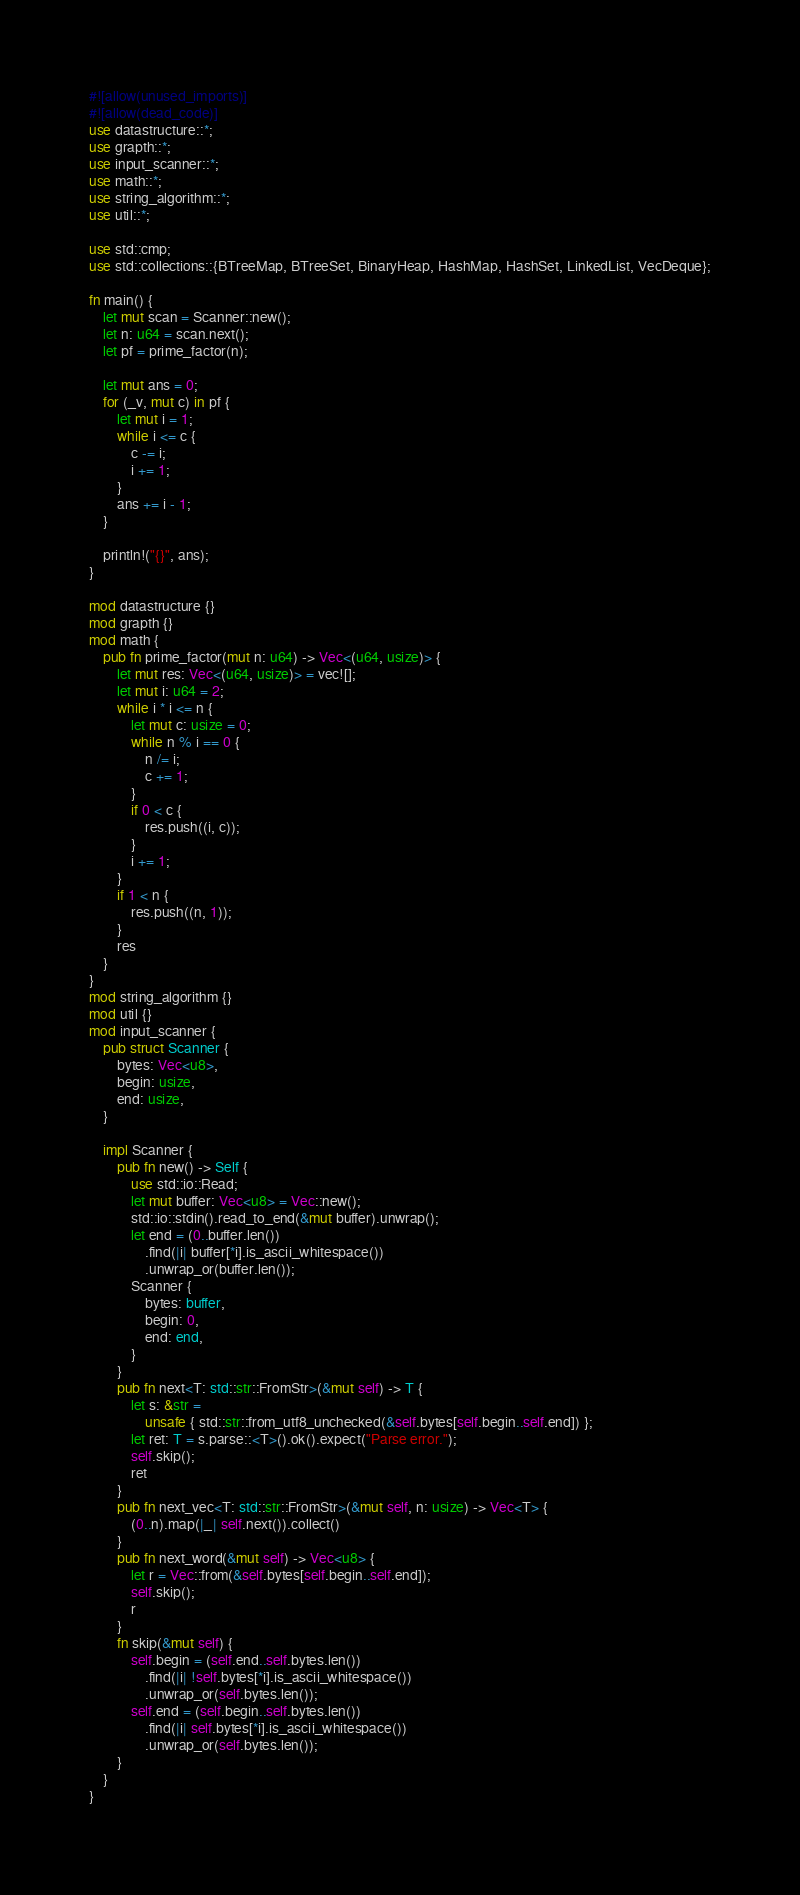Convert code to text. <code><loc_0><loc_0><loc_500><loc_500><_Rust_>#![allow(unused_imports)]
#![allow(dead_code)]
use datastructure::*;
use grapth::*;
use input_scanner::*;
use math::*;
use string_algorithm::*;
use util::*;

use std::cmp;
use std::collections::{BTreeMap, BTreeSet, BinaryHeap, HashMap, HashSet, LinkedList, VecDeque};

fn main() {
    let mut scan = Scanner::new();
    let n: u64 = scan.next();
    let pf = prime_factor(n);

    let mut ans = 0;
    for (_v, mut c) in pf {
        let mut i = 1;
        while i <= c {
            c -= i;
            i += 1;
        }
        ans += i - 1;
    }

    println!("{}", ans);
}

mod datastructure {}
mod grapth {}
mod math {
    pub fn prime_factor(mut n: u64) -> Vec<(u64, usize)> {
        let mut res: Vec<(u64, usize)> = vec![];
        let mut i: u64 = 2;
        while i * i <= n {
            let mut c: usize = 0;
            while n % i == 0 {
                n /= i;
                c += 1;
            }
            if 0 < c {
                res.push((i, c));
            }
            i += 1;
        }
        if 1 < n {
            res.push((n, 1));
        }
        res
    }
}
mod string_algorithm {}
mod util {}
mod input_scanner {
    pub struct Scanner {
        bytes: Vec<u8>,
        begin: usize,
        end: usize,
    }

    impl Scanner {
        pub fn new() -> Self {
            use std::io::Read;
            let mut buffer: Vec<u8> = Vec::new();
            std::io::stdin().read_to_end(&mut buffer).unwrap();
            let end = (0..buffer.len())
                .find(|i| buffer[*i].is_ascii_whitespace())
                .unwrap_or(buffer.len());
            Scanner {
                bytes: buffer,
                begin: 0,
                end: end,
            }
        }
        pub fn next<T: std::str::FromStr>(&mut self) -> T {
            let s: &str =
                unsafe { std::str::from_utf8_unchecked(&self.bytes[self.begin..self.end]) };
            let ret: T = s.parse::<T>().ok().expect("Parse error.");
            self.skip();
            ret
        }
        pub fn next_vec<T: std::str::FromStr>(&mut self, n: usize) -> Vec<T> {
            (0..n).map(|_| self.next()).collect()
        }
        pub fn next_word(&mut self) -> Vec<u8> {
            let r = Vec::from(&self.bytes[self.begin..self.end]);
            self.skip();
            r
        }
        fn skip(&mut self) {
            self.begin = (self.end..self.bytes.len())
                .find(|i| !self.bytes[*i].is_ascii_whitespace())
                .unwrap_or(self.bytes.len());
            self.end = (self.begin..self.bytes.len())
                .find(|i| self.bytes[*i].is_ascii_whitespace())
                .unwrap_or(self.bytes.len());
        }
    }
}
</code> 